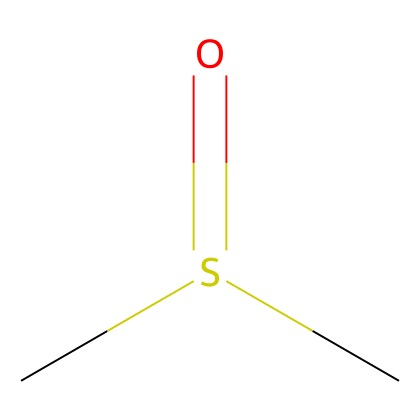What is the molecular formula of dimethyl sulfoxide? The SMILES representation shows two carbon atoms (C), one sulfur atom (S), and one oxygen atom (O), giving the formula C2H6OS.
Answer: C2H6OS How many hydrogen atoms are present in dimethyl sulfoxide? The SMILES representation indicates 6 hydrogen atoms attached to the two carbon atoms, making a total of 6.
Answer: 6 What type of sulfur compound is dimethyl sulfoxide classified as? Dimethyl sulfoxide features a sulfoxide functional group, where sulfur is bonded to oxygen, classifying it as a sulfoxide.
Answer: sulfoxide How many double bonds are present in dimethyl sulfoxide? Analyzing the structure, there is one double bond between sulfur and oxygen in the sulfoxide functional group.
Answer: 1 What is the hybridization of the sulfur atom in dimethyl sulfoxide? The sulfur atom in dimethyl sulfoxide is bonded to four groups (two carbon atoms and one oxygen atom), resulting in sp3 hybridization.
Answer: sp3 Does dimethyl sulfoxide have a polar or nonpolar character? The presence of the polar C-S and S=O bonds contributes to the overall polarity of dimethyl sulfoxide, making it polar.
Answer: polar What effect does the sulfoxide group have on the solubility properties of dimethyl sulfoxide? The sulfoxide group enhances the solubility of dimethyl sulfoxide in both polar and nonpolar solvents due to its unique properties.
Answer: enhances solubility 